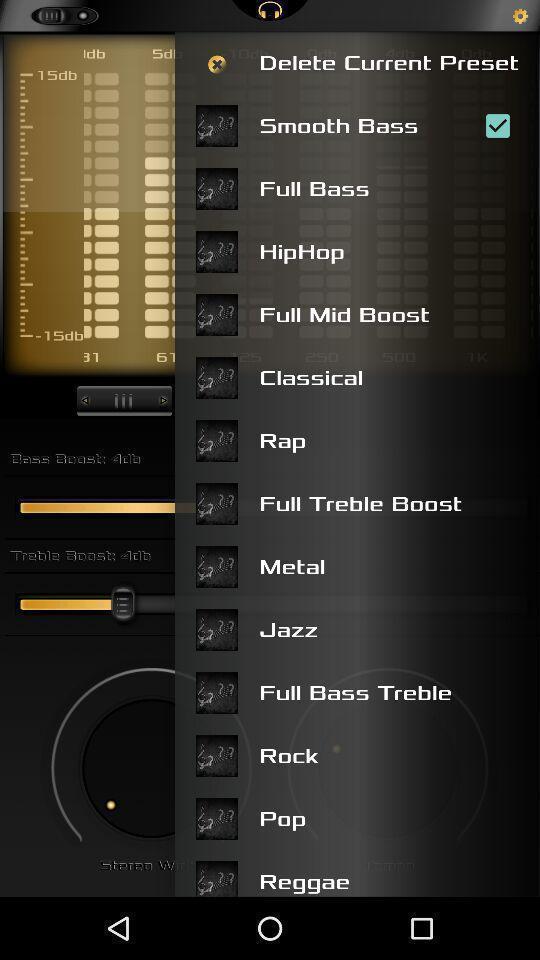Describe the visual elements of this screenshot. Popup slide with list of music options in music app. 